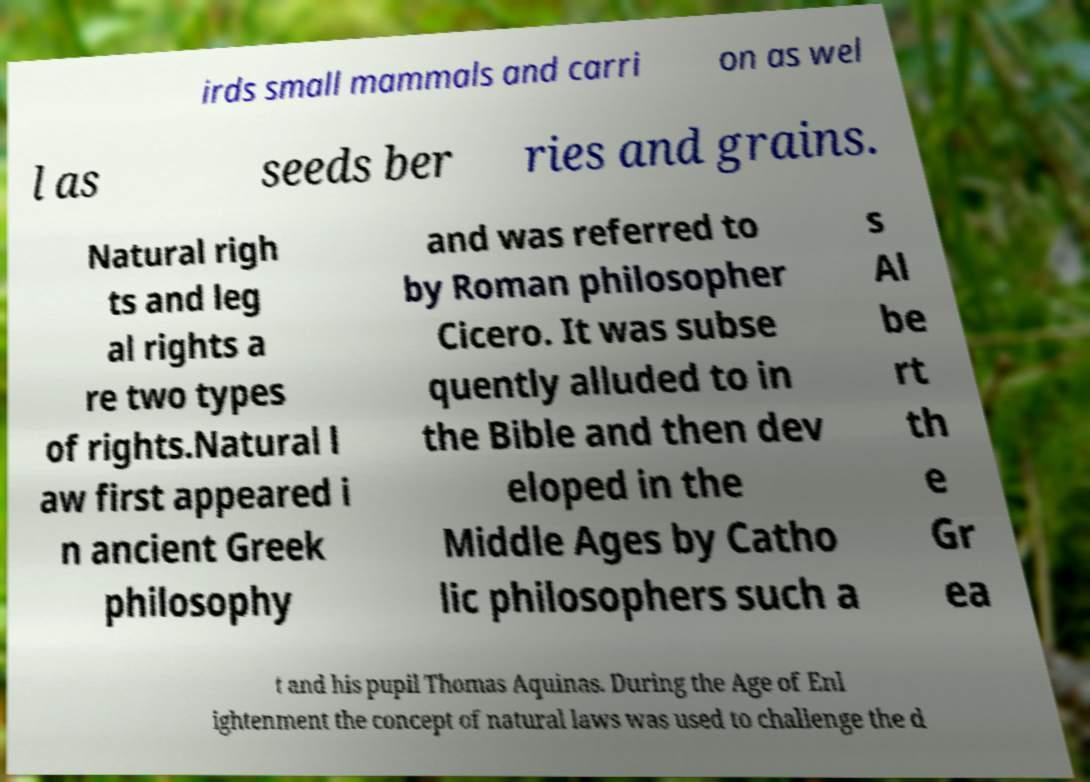I need the written content from this picture converted into text. Can you do that? irds small mammals and carri on as wel l as seeds ber ries and grains. Natural righ ts and leg al rights a re two types of rights.Natural l aw first appeared i n ancient Greek philosophy and was referred to by Roman philosopher Cicero. It was subse quently alluded to in the Bible and then dev eloped in the Middle Ages by Catho lic philosophers such a s Al be rt th e Gr ea t and his pupil Thomas Aquinas. During the Age of Enl ightenment the concept of natural laws was used to challenge the d 